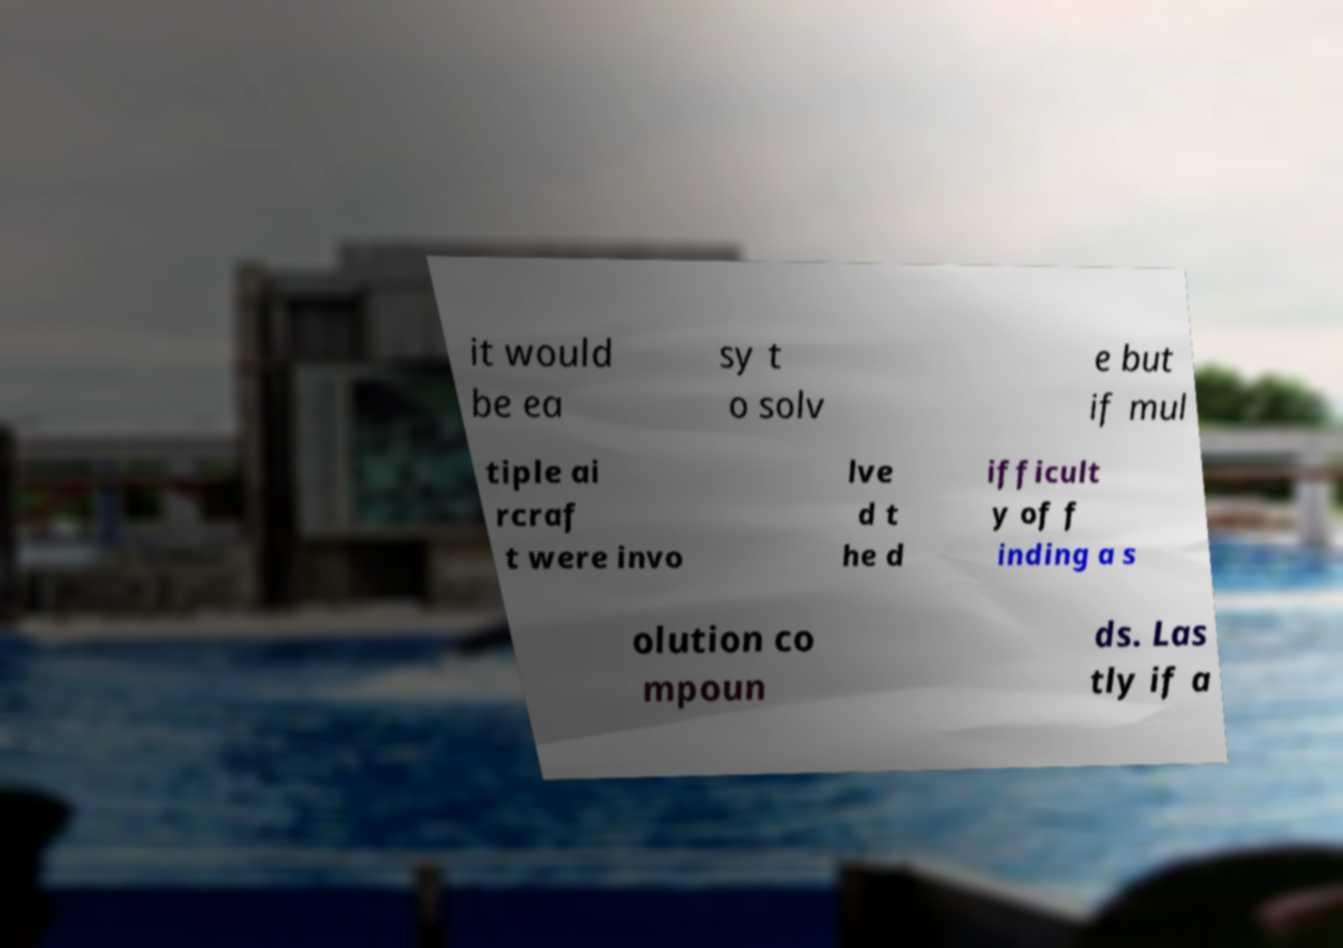Could you extract and type out the text from this image? it would be ea sy t o solv e but if mul tiple ai rcraf t were invo lve d t he d ifficult y of f inding a s olution co mpoun ds. Las tly if a 